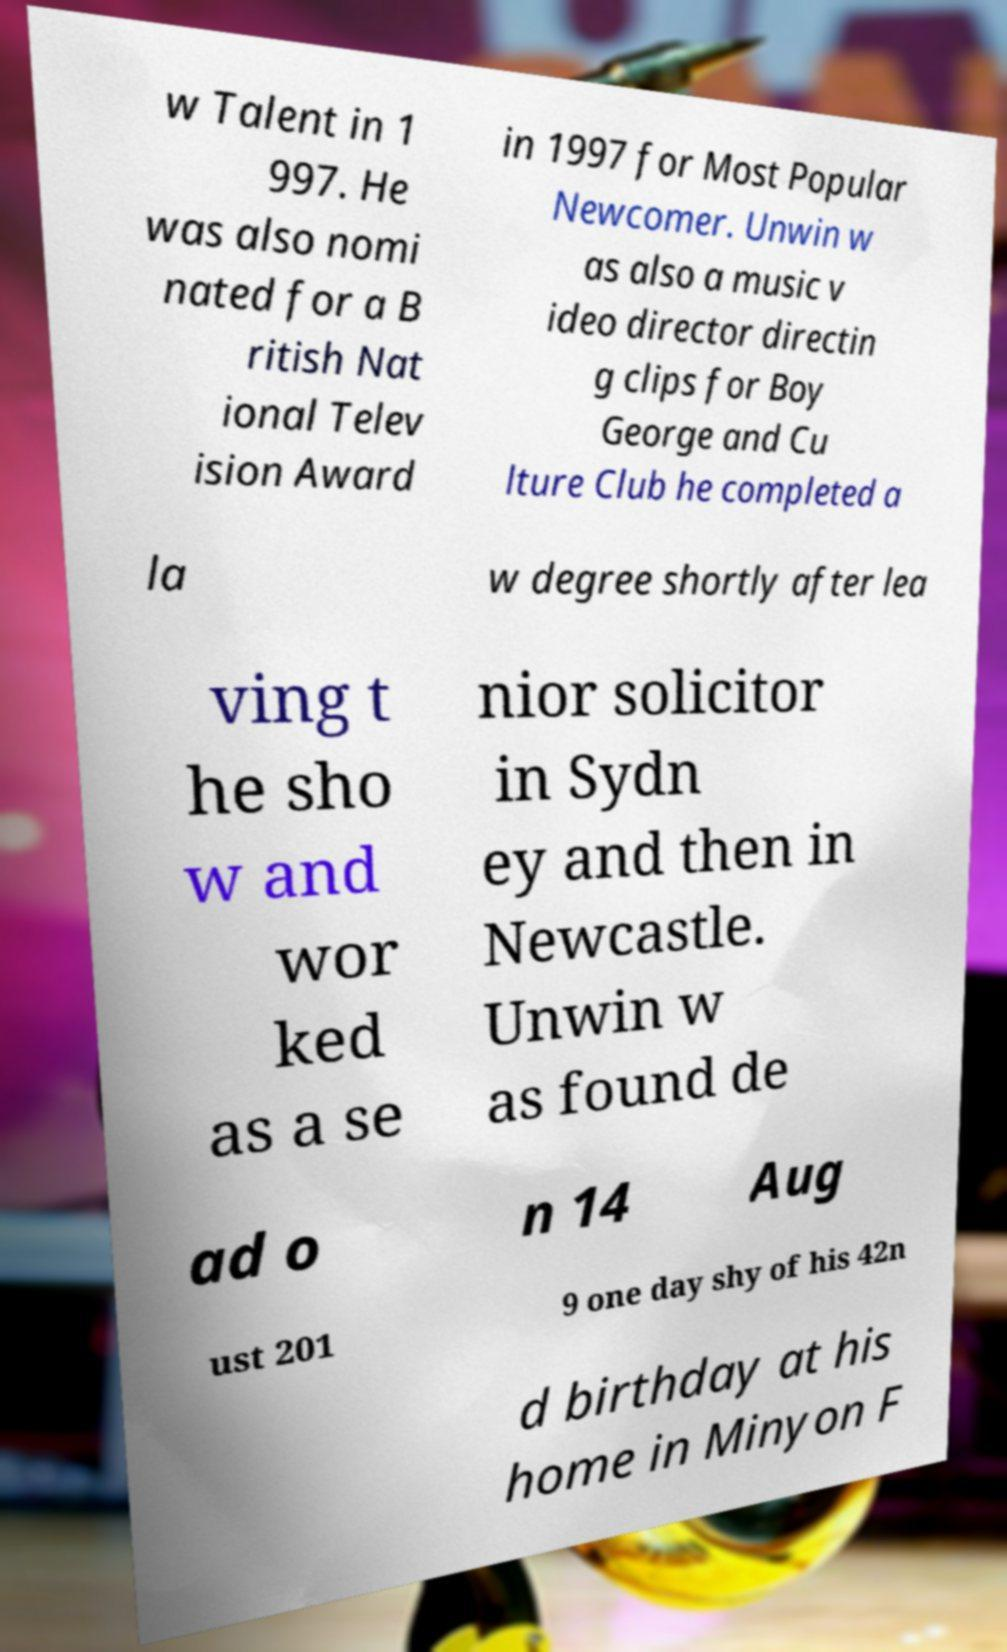Can you accurately transcribe the text from the provided image for me? w Talent in 1 997. He was also nomi nated for a B ritish Nat ional Telev ision Award in 1997 for Most Popular Newcomer. Unwin w as also a music v ideo director directin g clips for Boy George and Cu lture Club he completed a la w degree shortly after lea ving t he sho w and wor ked as a se nior solicitor in Sydn ey and then in Newcastle. Unwin w as found de ad o n 14 Aug ust 201 9 one day shy of his 42n d birthday at his home in Minyon F 